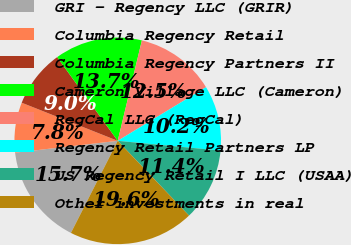Convert chart. <chart><loc_0><loc_0><loc_500><loc_500><pie_chart><fcel>GRI - Regency LLC (GRIR)<fcel>Columbia Regency Retail<fcel>Columbia Regency Partners II<fcel>Cameron Village LLC (Cameron)<fcel>RegCal LLC (RegCal)<fcel>Regency Retail Partners LP<fcel>US Regency Retail I LLC (USAA)<fcel>Other investments in real<nl><fcel>15.69%<fcel>7.84%<fcel>9.02%<fcel>13.73%<fcel>12.55%<fcel>10.2%<fcel>11.37%<fcel>19.61%<nl></chart> 